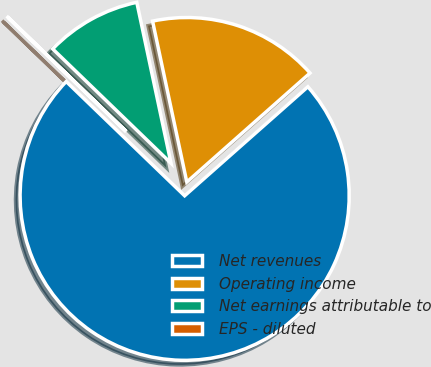Convert chart. <chart><loc_0><loc_0><loc_500><loc_500><pie_chart><fcel>Net revenues<fcel>Operating income<fcel>Net earnings attributable to<fcel>EPS - diluted<nl><fcel>73.75%<fcel>16.81%<fcel>9.44%<fcel>0.01%<nl></chart> 